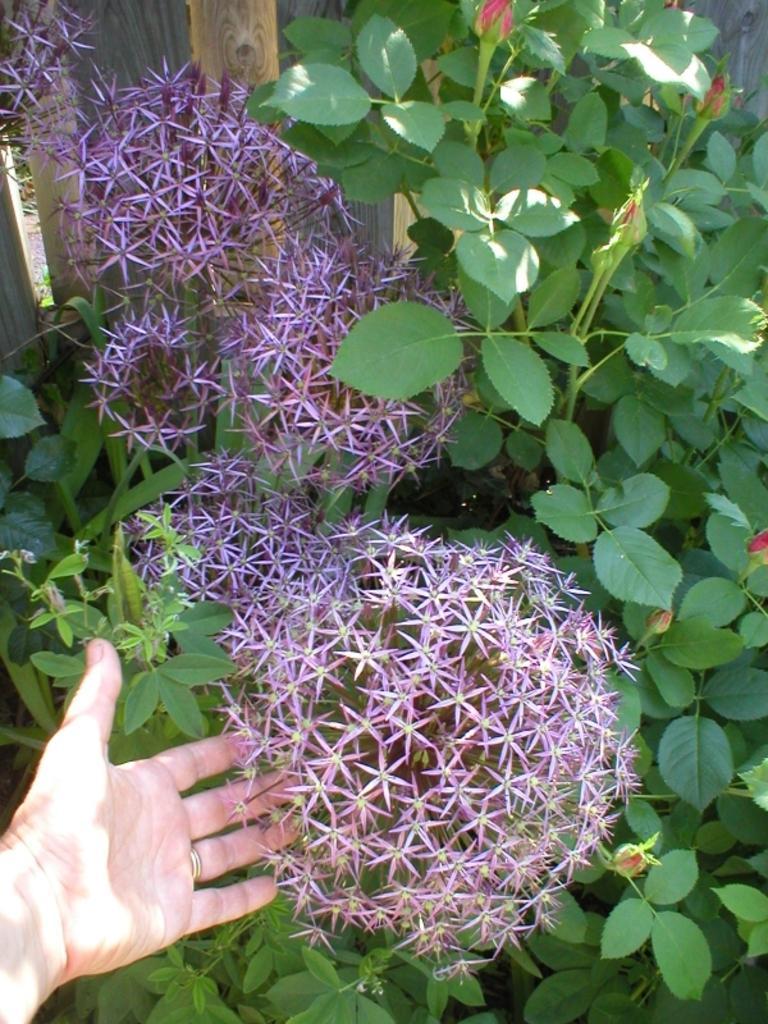Could you give a brief overview of what you see in this image? In this image I can see the person´s hand and I can also see few flowers in purple and red color, leaves in green color. In the background I can see the wooden fencing. 